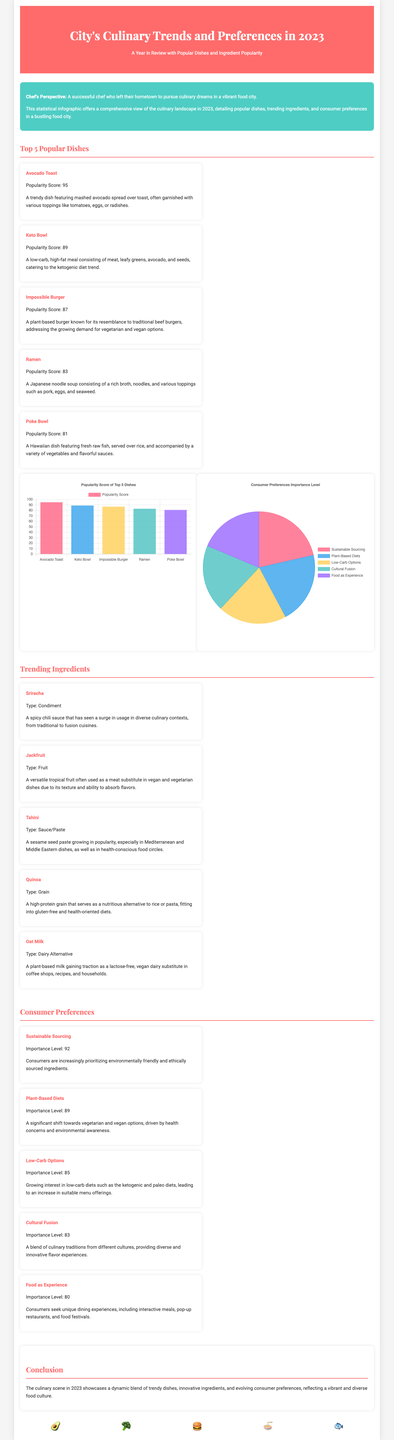what is the popularity score of Avocado Toast? The popularity score is listed directly in the document as 95.
Answer: 95 which dish is known for its resemblance to traditional beef burgers? This refers to the Impossible Burger, which is described as a plant-based burger addressing the demand for vegetarian and vegan options.
Answer: Impossible Burger what ingredient type is Sriracha classified as? The document specifically categorizes Sriracha as a condiment.
Answer: Condiment what is the importance level of Sustainable Sourcing? The document states that Sustainable Sourcing has an importance level of 92.
Answer: 92 which dish ranks fifth in popularity? The fifth highest-ranked dish is Poke Bowl according to the popularity scores listed.
Answer: Poke Bowl which ingredient is gaining traction as a lactose-free alternative? Oat Milk is mentioned as a plant-based milk gaining traction as a lactose-free substitute.
Answer: Oat Milk what is the primary consumer trend concerning dietary options? The document highlights "Plant-Based Diets" as a significant consumer preference trend.
Answer: Plant-Based Diets how many popular dishes are listed in the document? The document lists a total of five popular dishes.
Answer: 5 what is the importance level of Food as Experience? The document states that Food as Experience has an importance level of 80.
Answer: 80 which dish features fresh raw fish served over rice? The Poke Bowl is described as featuring fresh raw fish served over rice.
Answer: Poke Bowl 